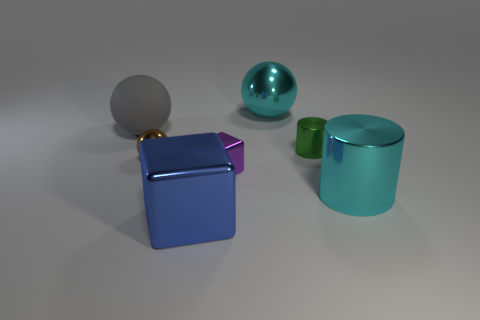Add 1 cyan spheres. How many objects exist? 8 Subtract all metallic balls. How many balls are left? 1 Subtract all cylinders. How many objects are left? 5 Subtract 1 blocks. How many blocks are left? 1 Add 5 small objects. How many small objects exist? 8 Subtract all cyan cylinders. How many cylinders are left? 1 Subtract 0 brown cylinders. How many objects are left? 7 Subtract all blue cubes. Subtract all green balls. How many cubes are left? 1 Subtract all tiny purple objects. Subtract all gray things. How many objects are left? 5 Add 7 green metal cylinders. How many green metal cylinders are left? 8 